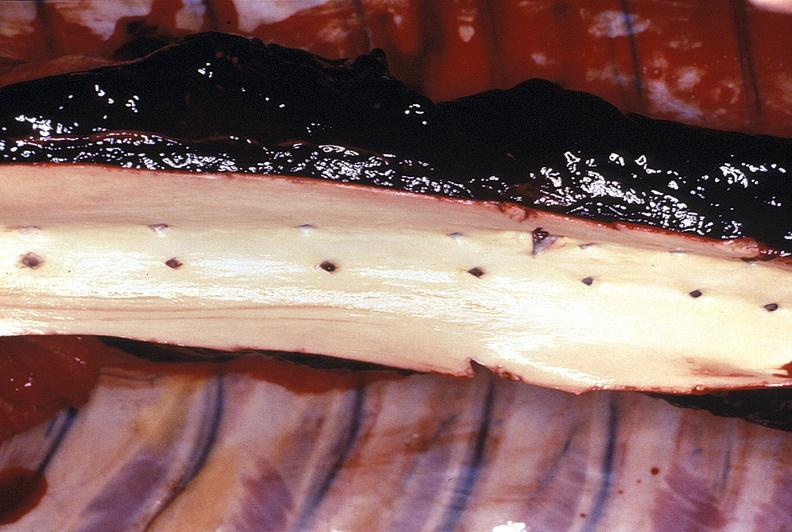s cardiovascular present?
Answer the question using a single word or phrase. Yes 